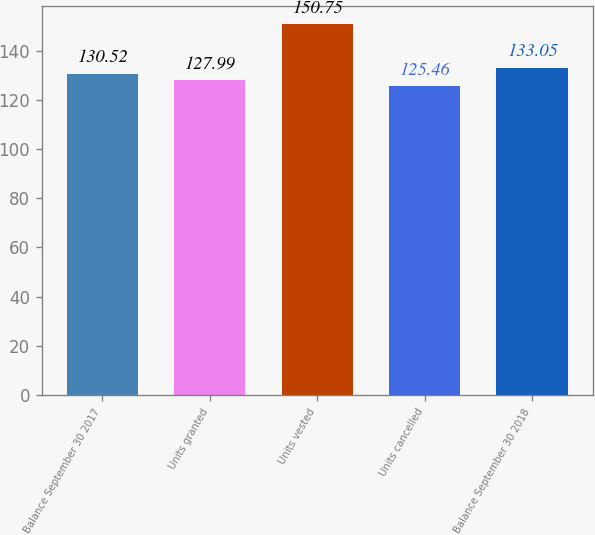Convert chart to OTSL. <chart><loc_0><loc_0><loc_500><loc_500><bar_chart><fcel>Balance September 30 2017<fcel>Units granted<fcel>Units vested<fcel>Units cancelled<fcel>Balance September 30 2018<nl><fcel>130.52<fcel>127.99<fcel>150.75<fcel>125.46<fcel>133.05<nl></chart> 